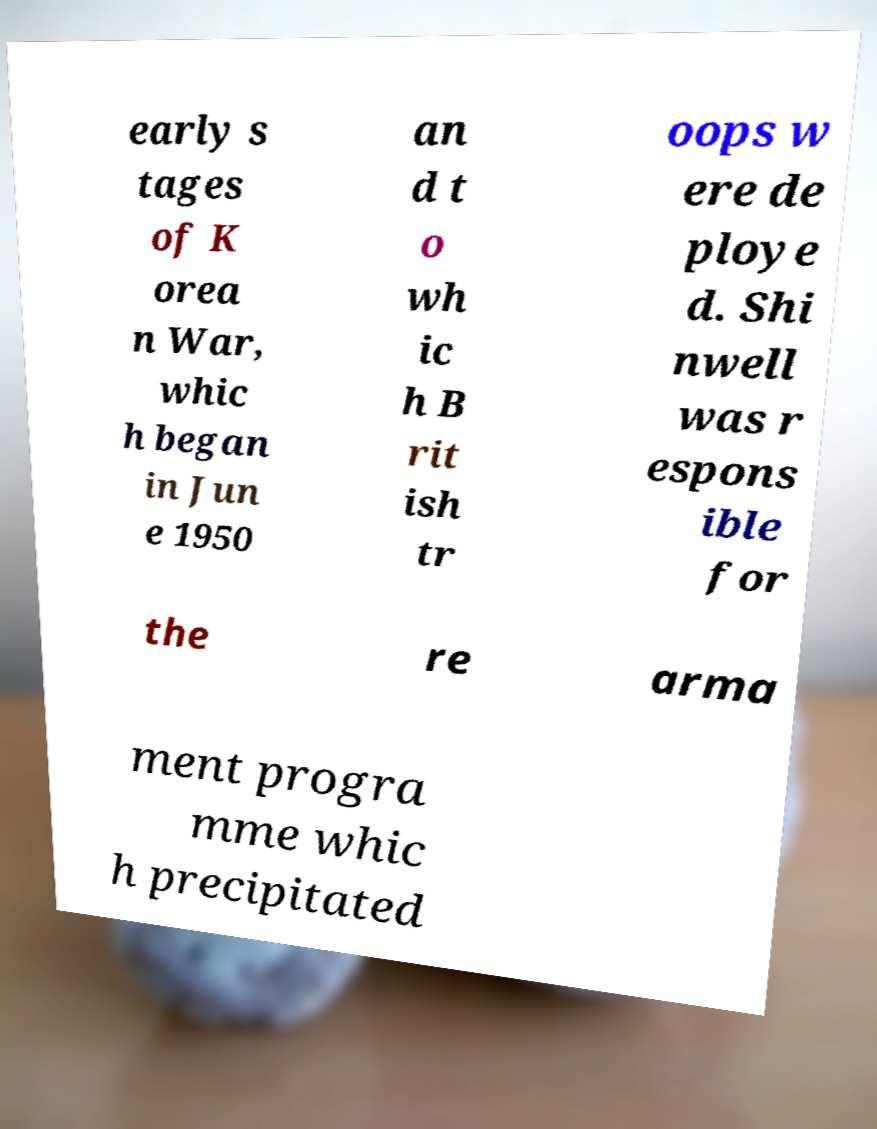Could you extract and type out the text from this image? early s tages of K orea n War, whic h began in Jun e 1950 an d t o wh ic h B rit ish tr oops w ere de ploye d. Shi nwell was r espons ible for the re arma ment progra mme whic h precipitated 